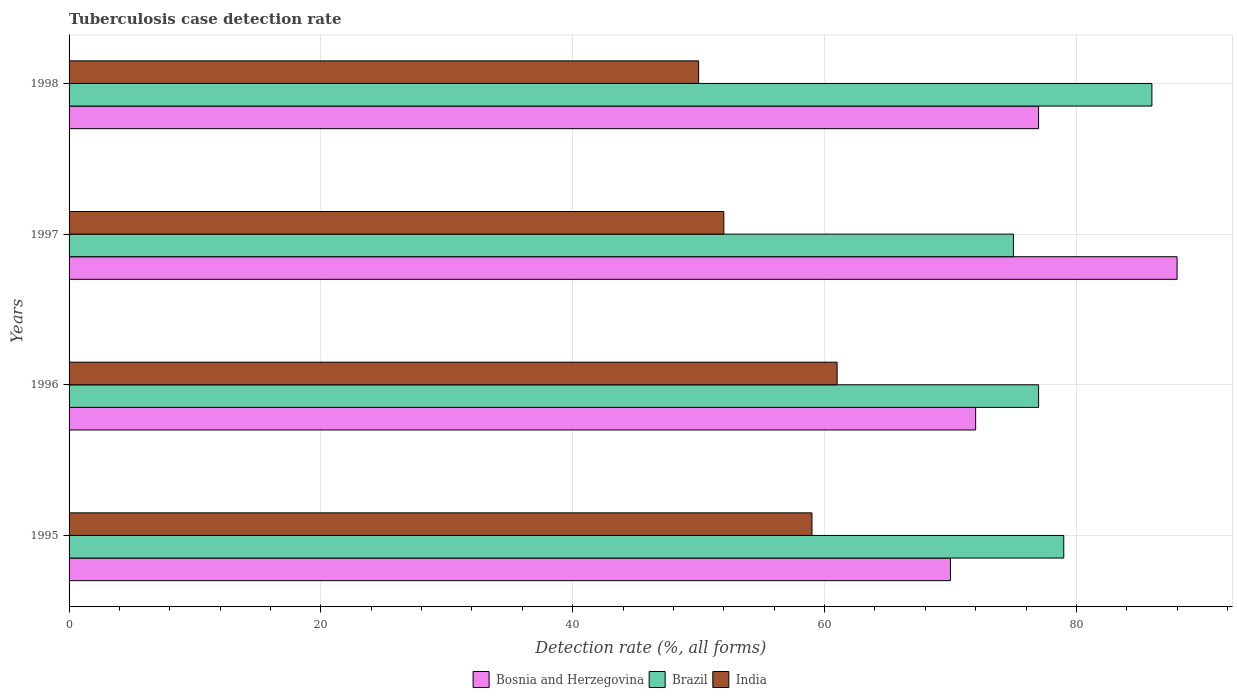Are the number of bars per tick equal to the number of legend labels?
Offer a very short reply. Yes. Are the number of bars on each tick of the Y-axis equal?
Make the answer very short. Yes. How many bars are there on the 4th tick from the top?
Your answer should be very brief. 3. What is the tuberculosis case detection rate in in Bosnia and Herzegovina in 1997?
Your answer should be compact. 88. Across all years, what is the maximum tuberculosis case detection rate in in India?
Offer a very short reply. 61. Across all years, what is the minimum tuberculosis case detection rate in in Brazil?
Keep it short and to the point. 75. In which year was the tuberculosis case detection rate in in Bosnia and Herzegovina maximum?
Your response must be concise. 1997. In which year was the tuberculosis case detection rate in in Bosnia and Herzegovina minimum?
Keep it short and to the point. 1995. What is the total tuberculosis case detection rate in in Brazil in the graph?
Your answer should be very brief. 317. What is the average tuberculosis case detection rate in in Brazil per year?
Make the answer very short. 79.25. In how many years, is the tuberculosis case detection rate in in India greater than 60 %?
Offer a very short reply. 1. What is the ratio of the tuberculosis case detection rate in in Bosnia and Herzegovina in 1995 to that in 1996?
Make the answer very short. 0.97. Is the tuberculosis case detection rate in in Brazil in 1996 less than that in 1997?
Provide a succinct answer. No. What is the difference between the highest and the second highest tuberculosis case detection rate in in Brazil?
Keep it short and to the point. 7. What is the difference between the highest and the lowest tuberculosis case detection rate in in Bosnia and Herzegovina?
Your answer should be very brief. 18. In how many years, is the tuberculosis case detection rate in in India greater than the average tuberculosis case detection rate in in India taken over all years?
Your answer should be very brief. 2. Is the sum of the tuberculosis case detection rate in in India in 1995 and 1997 greater than the maximum tuberculosis case detection rate in in Bosnia and Herzegovina across all years?
Ensure brevity in your answer.  Yes. What does the 3rd bar from the bottom in 1998 represents?
Your response must be concise. India. How many bars are there?
Your answer should be compact. 12. How many years are there in the graph?
Give a very brief answer. 4. What is the difference between two consecutive major ticks on the X-axis?
Provide a succinct answer. 20. Does the graph contain any zero values?
Give a very brief answer. No. Does the graph contain grids?
Your answer should be compact. Yes. How many legend labels are there?
Ensure brevity in your answer.  3. How are the legend labels stacked?
Give a very brief answer. Horizontal. What is the title of the graph?
Your answer should be very brief. Tuberculosis case detection rate. What is the label or title of the X-axis?
Offer a terse response. Detection rate (%, all forms). What is the Detection rate (%, all forms) of Brazil in 1995?
Offer a very short reply. 79. What is the Detection rate (%, all forms) in India in 1995?
Provide a short and direct response. 59. What is the Detection rate (%, all forms) of Bosnia and Herzegovina in 1996?
Your answer should be very brief. 72. What is the Detection rate (%, all forms) in India in 1997?
Make the answer very short. 52. What is the Detection rate (%, all forms) of Bosnia and Herzegovina in 1998?
Offer a terse response. 77. Across all years, what is the minimum Detection rate (%, all forms) of Brazil?
Your answer should be very brief. 75. What is the total Detection rate (%, all forms) in Bosnia and Herzegovina in the graph?
Make the answer very short. 307. What is the total Detection rate (%, all forms) in Brazil in the graph?
Ensure brevity in your answer.  317. What is the total Detection rate (%, all forms) of India in the graph?
Your response must be concise. 222. What is the difference between the Detection rate (%, all forms) of Bosnia and Herzegovina in 1995 and that in 1998?
Offer a very short reply. -7. What is the difference between the Detection rate (%, all forms) of India in 1995 and that in 1998?
Make the answer very short. 9. What is the difference between the Detection rate (%, all forms) of Bosnia and Herzegovina in 1996 and that in 1997?
Provide a succinct answer. -16. What is the difference between the Detection rate (%, all forms) in Brazil in 1996 and that in 1997?
Keep it short and to the point. 2. What is the difference between the Detection rate (%, all forms) of Bosnia and Herzegovina in 1996 and that in 1998?
Your answer should be compact. -5. What is the difference between the Detection rate (%, all forms) in India in 1996 and that in 1998?
Your answer should be very brief. 11. What is the difference between the Detection rate (%, all forms) in Bosnia and Herzegovina in 1997 and that in 1998?
Offer a terse response. 11. What is the difference between the Detection rate (%, all forms) in India in 1997 and that in 1998?
Keep it short and to the point. 2. What is the difference between the Detection rate (%, all forms) of Bosnia and Herzegovina in 1995 and the Detection rate (%, all forms) of India in 1996?
Offer a terse response. 9. What is the difference between the Detection rate (%, all forms) in Bosnia and Herzegovina in 1995 and the Detection rate (%, all forms) in India in 1997?
Offer a terse response. 18. What is the difference between the Detection rate (%, all forms) of Bosnia and Herzegovina in 1996 and the Detection rate (%, all forms) of India in 1997?
Provide a succinct answer. 20. What is the difference between the Detection rate (%, all forms) in Bosnia and Herzegovina in 1996 and the Detection rate (%, all forms) in Brazil in 1998?
Your response must be concise. -14. What is the difference between the Detection rate (%, all forms) of Brazil in 1996 and the Detection rate (%, all forms) of India in 1998?
Give a very brief answer. 27. What is the average Detection rate (%, all forms) in Bosnia and Herzegovina per year?
Give a very brief answer. 76.75. What is the average Detection rate (%, all forms) of Brazil per year?
Your answer should be compact. 79.25. What is the average Detection rate (%, all forms) in India per year?
Your response must be concise. 55.5. In the year 1995, what is the difference between the Detection rate (%, all forms) in Bosnia and Herzegovina and Detection rate (%, all forms) in Brazil?
Ensure brevity in your answer.  -9. In the year 1995, what is the difference between the Detection rate (%, all forms) in Brazil and Detection rate (%, all forms) in India?
Make the answer very short. 20. In the year 1996, what is the difference between the Detection rate (%, all forms) in Bosnia and Herzegovina and Detection rate (%, all forms) in Brazil?
Offer a terse response. -5. In the year 1997, what is the difference between the Detection rate (%, all forms) of Bosnia and Herzegovina and Detection rate (%, all forms) of Brazil?
Make the answer very short. 13. In the year 1997, what is the difference between the Detection rate (%, all forms) in Brazil and Detection rate (%, all forms) in India?
Your response must be concise. 23. In the year 1998, what is the difference between the Detection rate (%, all forms) of Bosnia and Herzegovina and Detection rate (%, all forms) of India?
Give a very brief answer. 27. What is the ratio of the Detection rate (%, all forms) in Bosnia and Herzegovina in 1995 to that in 1996?
Your response must be concise. 0.97. What is the ratio of the Detection rate (%, all forms) of Brazil in 1995 to that in 1996?
Provide a succinct answer. 1.03. What is the ratio of the Detection rate (%, all forms) of India in 1995 to that in 1996?
Ensure brevity in your answer.  0.97. What is the ratio of the Detection rate (%, all forms) in Bosnia and Herzegovina in 1995 to that in 1997?
Provide a succinct answer. 0.8. What is the ratio of the Detection rate (%, all forms) of Brazil in 1995 to that in 1997?
Provide a short and direct response. 1.05. What is the ratio of the Detection rate (%, all forms) of India in 1995 to that in 1997?
Make the answer very short. 1.13. What is the ratio of the Detection rate (%, all forms) of Brazil in 1995 to that in 1998?
Ensure brevity in your answer.  0.92. What is the ratio of the Detection rate (%, all forms) of India in 1995 to that in 1998?
Provide a short and direct response. 1.18. What is the ratio of the Detection rate (%, all forms) of Bosnia and Herzegovina in 1996 to that in 1997?
Ensure brevity in your answer.  0.82. What is the ratio of the Detection rate (%, all forms) of Brazil in 1996 to that in 1997?
Ensure brevity in your answer.  1.03. What is the ratio of the Detection rate (%, all forms) of India in 1996 to that in 1997?
Your response must be concise. 1.17. What is the ratio of the Detection rate (%, all forms) in Bosnia and Herzegovina in 1996 to that in 1998?
Give a very brief answer. 0.94. What is the ratio of the Detection rate (%, all forms) of Brazil in 1996 to that in 1998?
Keep it short and to the point. 0.9. What is the ratio of the Detection rate (%, all forms) of India in 1996 to that in 1998?
Give a very brief answer. 1.22. What is the ratio of the Detection rate (%, all forms) of Brazil in 1997 to that in 1998?
Make the answer very short. 0.87. What is the ratio of the Detection rate (%, all forms) in India in 1997 to that in 1998?
Give a very brief answer. 1.04. What is the difference between the highest and the second highest Detection rate (%, all forms) in Bosnia and Herzegovina?
Offer a very short reply. 11. What is the difference between the highest and the lowest Detection rate (%, all forms) in Brazil?
Make the answer very short. 11. 